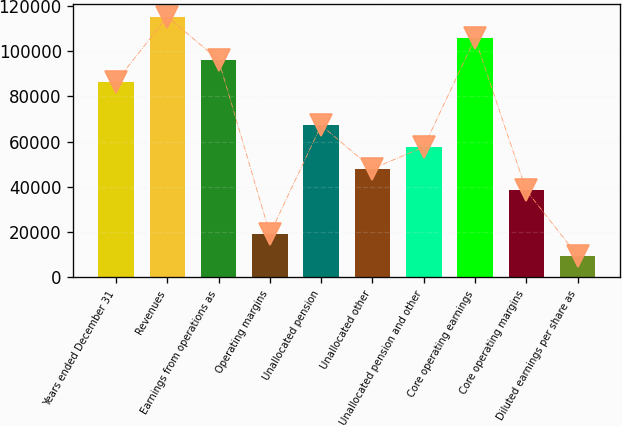Convert chart. <chart><loc_0><loc_0><loc_500><loc_500><bar_chart><fcel>Years ended December 31<fcel>Revenues<fcel>Earnings from operations as<fcel>Operating margins<fcel>Unallocated pension<fcel>Unallocated other<fcel>Unallocated pension and other<fcel>Core operating earnings<fcel>Core operating margins<fcel>Diluted earnings per share as<nl><fcel>86502.6<fcel>115337<fcel>96114<fcel>19222.9<fcel>67279.9<fcel>48057.1<fcel>57668.5<fcel>105725<fcel>38445.7<fcel>9611.53<nl></chart> 